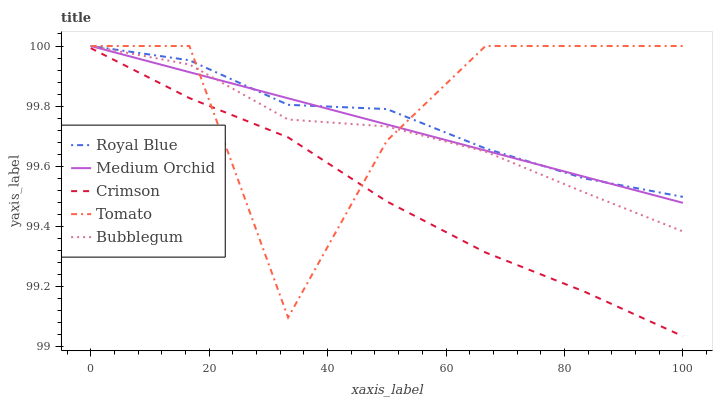Does Crimson have the minimum area under the curve?
Answer yes or no. Yes. Does Tomato have the maximum area under the curve?
Answer yes or no. Yes. Does Royal Blue have the minimum area under the curve?
Answer yes or no. No. Does Royal Blue have the maximum area under the curve?
Answer yes or no. No. Is Medium Orchid the smoothest?
Answer yes or no. Yes. Is Tomato the roughest?
Answer yes or no. Yes. Is Royal Blue the smoothest?
Answer yes or no. No. Is Royal Blue the roughest?
Answer yes or no. No. Does Crimson have the lowest value?
Answer yes or no. Yes. Does Tomato have the lowest value?
Answer yes or no. No. Does Bubblegum have the highest value?
Answer yes or no. Yes. Is Crimson less than Royal Blue?
Answer yes or no. Yes. Is Bubblegum greater than Crimson?
Answer yes or no. Yes. Does Royal Blue intersect Bubblegum?
Answer yes or no. Yes. Is Royal Blue less than Bubblegum?
Answer yes or no. No. Is Royal Blue greater than Bubblegum?
Answer yes or no. No. Does Crimson intersect Royal Blue?
Answer yes or no. No. 